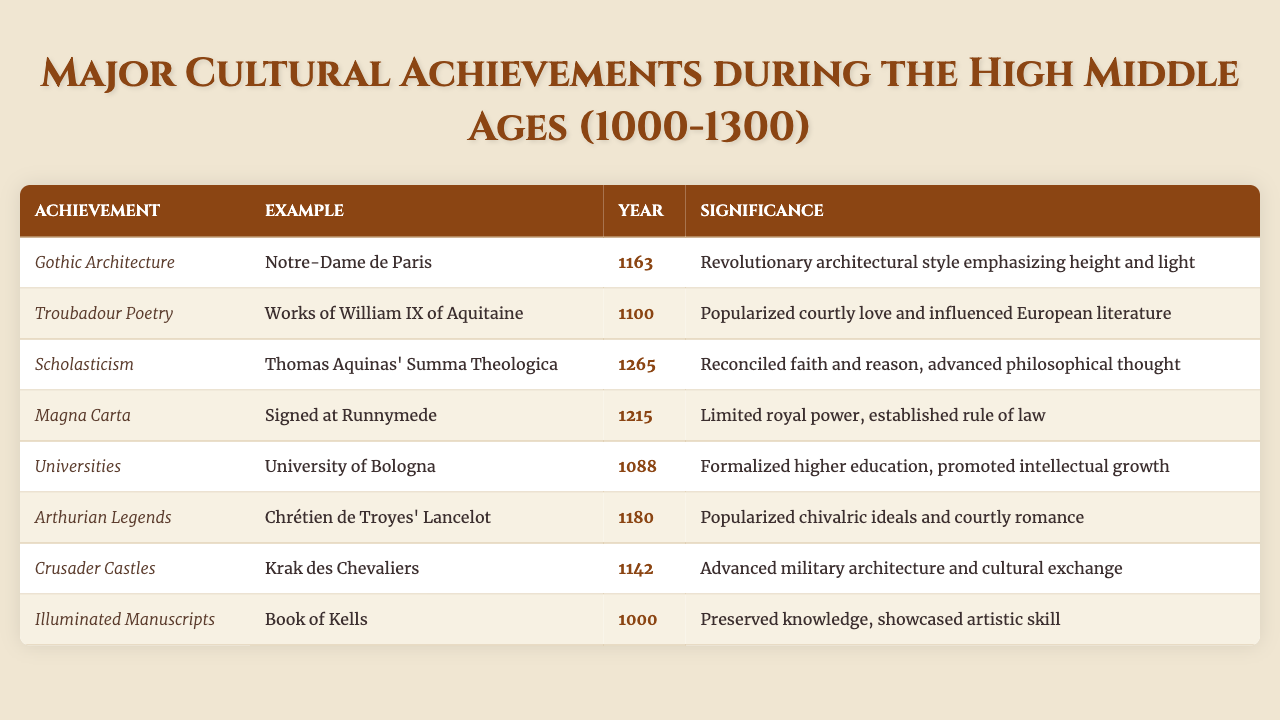What is the significance of Gothic Architecture? The table states that Gothic Architecture, exemplified by Notre-Dame de Paris (1163), is significant for emphasizing height and light, marking it as a revolutionary architectural style.
Answer: Revolutionary architectural style emphasizing height and light Which cultural achievement was associated with the year 1100? From the table, the cultural achievement linked to 1100 is Troubadour Poetry, specifically the works of William IX of Aquitaine.
Answer: Troubadour Poetry What is an example of Scholasticism? According to the table, an example of Scholasticism is Thomas Aquinas' "Summa Theologica," which was published in 1265.
Answer: "Summa Theologica" by Thomas Aquinas True or False: The Magna Carta was signed in 1200. The table provides the year of the Magna Carta as 1215, indicating that the statement is false.
Answer: False How many achievements listed occurred before the year 1150? In the table, the achievements that occurred before 1150 are Gothic Architecture (1163), Troubadour Poetry (1100), and Illuminated Manuscripts (1000). Therefore, there are four achievements (Illuminated Manuscripts, Troubadour Poetry, Crusader Castles, and Universities) recorded prior to 1150.
Answer: Four achievements Which achievement emphasizes the preservation of knowledge? The table specifies that Illuminated Manuscripts, such as the Book of Kells (1000), are significant for preserving knowledge.
Answer: Illuminated Manuscripts What was the main theme promoted by Arthurian Legends? The table indicates that Arthurian Legends, specifically the works of Chrétien de Troyes (1180), popularized chivalric ideals and courtly romance, making them central themes of that achievement.
Answer: Chivalric ideals and courtly romance How does the significance of Magna Carta differ from that of Scholasticism? Magna Carta (1215) limited royal power and established rule of law, while Scholasticism (1265), represented by Aquinas’ work, reconciled faith and reason, advancing philosophical thought. Thus, one addresses governance and the other philosophical inquiry.
Answer: Governance vs. philosophical inquiry List the cultural achievements that occurred in the 12th century. The table shows that the cultural achievements in the 12th century are Gothic Architecture (1163), Crusader Castles (1142), and Arthurian Legends (1180). Therefore, three achievements took place during this century.
Answer: Three achievements 